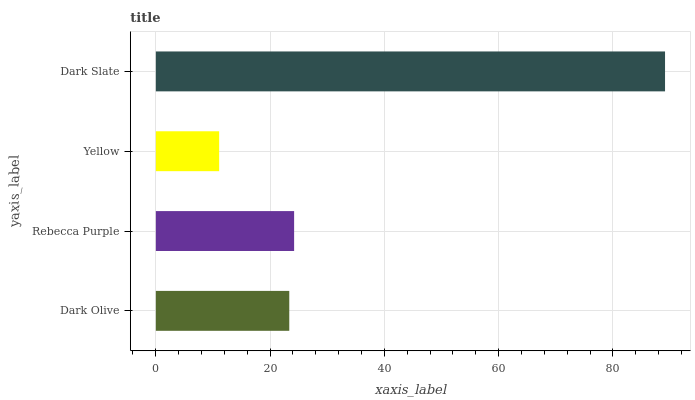Is Yellow the minimum?
Answer yes or no. Yes. Is Dark Slate the maximum?
Answer yes or no. Yes. Is Rebecca Purple the minimum?
Answer yes or no. No. Is Rebecca Purple the maximum?
Answer yes or no. No. Is Rebecca Purple greater than Dark Olive?
Answer yes or no. Yes. Is Dark Olive less than Rebecca Purple?
Answer yes or no. Yes. Is Dark Olive greater than Rebecca Purple?
Answer yes or no. No. Is Rebecca Purple less than Dark Olive?
Answer yes or no. No. Is Rebecca Purple the high median?
Answer yes or no. Yes. Is Dark Olive the low median?
Answer yes or no. Yes. Is Yellow the high median?
Answer yes or no. No. Is Dark Slate the low median?
Answer yes or no. No. 